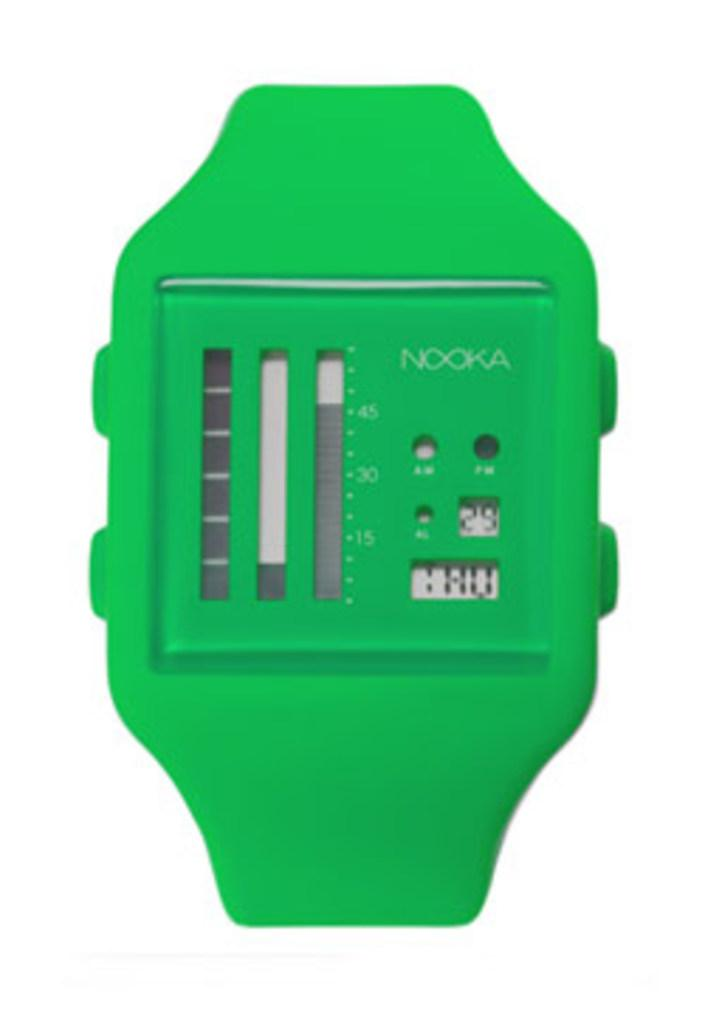Provide a one-sentence caption for the provided image. a watch face that is green and says 'nooka' on it and says 29 on it as well. 